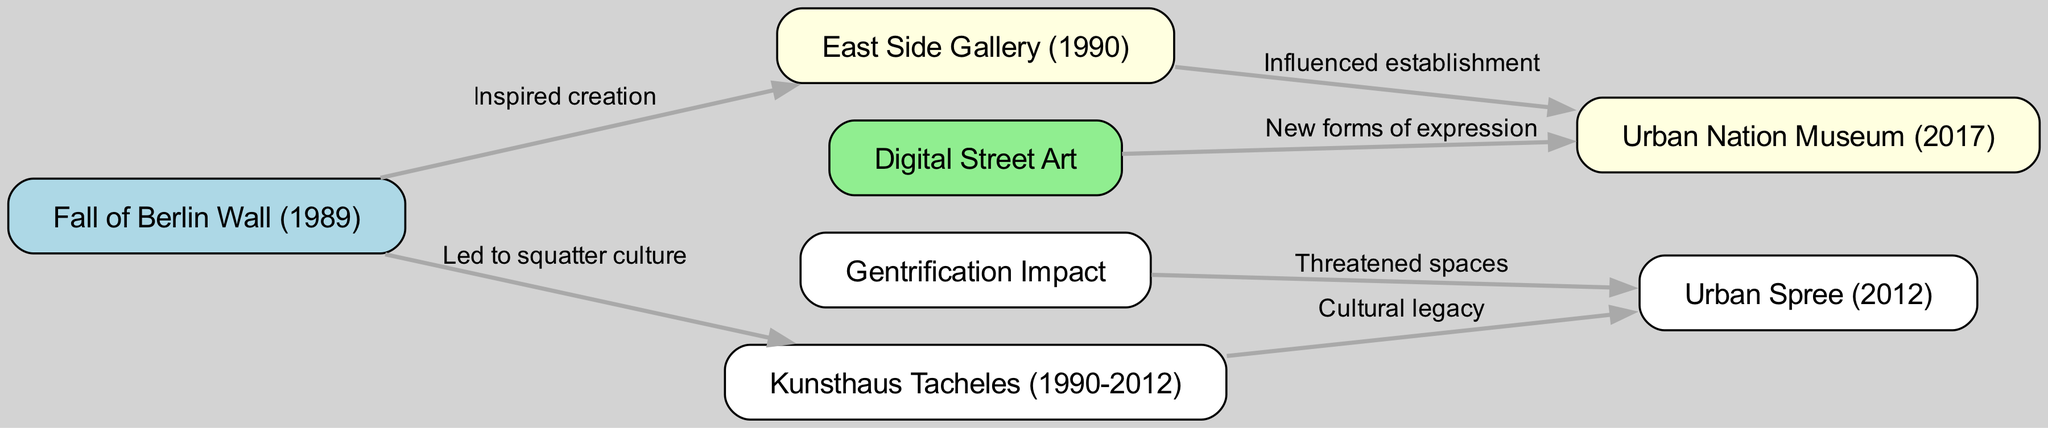What event inspired the creation of the East Side Gallery? The diagram shows an edge labeled "Inspired creation" connecting "Fall of Berlin Wall (1989)" to "East Side Gallery (1990)", indicating that the fall of the Berlin Wall was the inspirational event for its creation.
Answer: Fall of Berlin Wall How many nodes are present in the diagram? By counting the nodes listed in the data, we find there are 6 nodes: Fall of Berlin Wall, East Side Gallery, Kunsthaus Tacheles, Urban Spree, Urban Nation Museum, and Digital Street Art.
Answer: 6 Which node represents a cultural legacy that led to Urban Spree? The edge labeled "Cultural legacy" connects "Kunsthaus Tacheles" to "Urban Spree", indicating that Kunsthaus Tacheles is viewed as a cultural legacy that contributed to the establishment of Urban Spree.
Answer: Kunsthaus Tacheles What is the impact of gentrification on Urban Spree? The diagram shows an edge labeled "Threatened spaces" connecting "Gentrification Impact" to "Urban Spree". This indicates that gentrification poses a threat to the spaces where Urban Spree is located.
Answer: Threatened spaces Which museum was influenced by the establishment of the East Side Gallery? The edge labeled "Influenced establishment" connects "East Side Gallery" to "Urban Nation Museum", meaning that the East Side Gallery had a significant influence on the establishment of the Urban Nation Museum.
Answer: Urban Nation Museum What new forms of expression does Digital Street Art represent? The diagram shows an edge labeled "New forms of expression" connecting "Digital Street Art" to "Urban Nation Museum", indicating that Digital Street Art brings in new forms of expression relevant to the context of the Urban Nation Museum.
Answer: New forms of expression What year was Urban Spree established? In the diagram, Urban Spree is listed with the label "Urban Spree (2012)", indicating that it was established in the year 2012.
Answer: 2012 How does the fall of the Berlin Wall relate to squatter culture? The edge labeled "Led to squatter culture" connects "Fall of Berlin Wall (1989)" to "Kunsthaus Tacheles", indicating that the fall of the Berlin Wall gave rise to a squatter culture exemplified by Kunsthaus Tacheles.
Answer: Led to squatter culture 